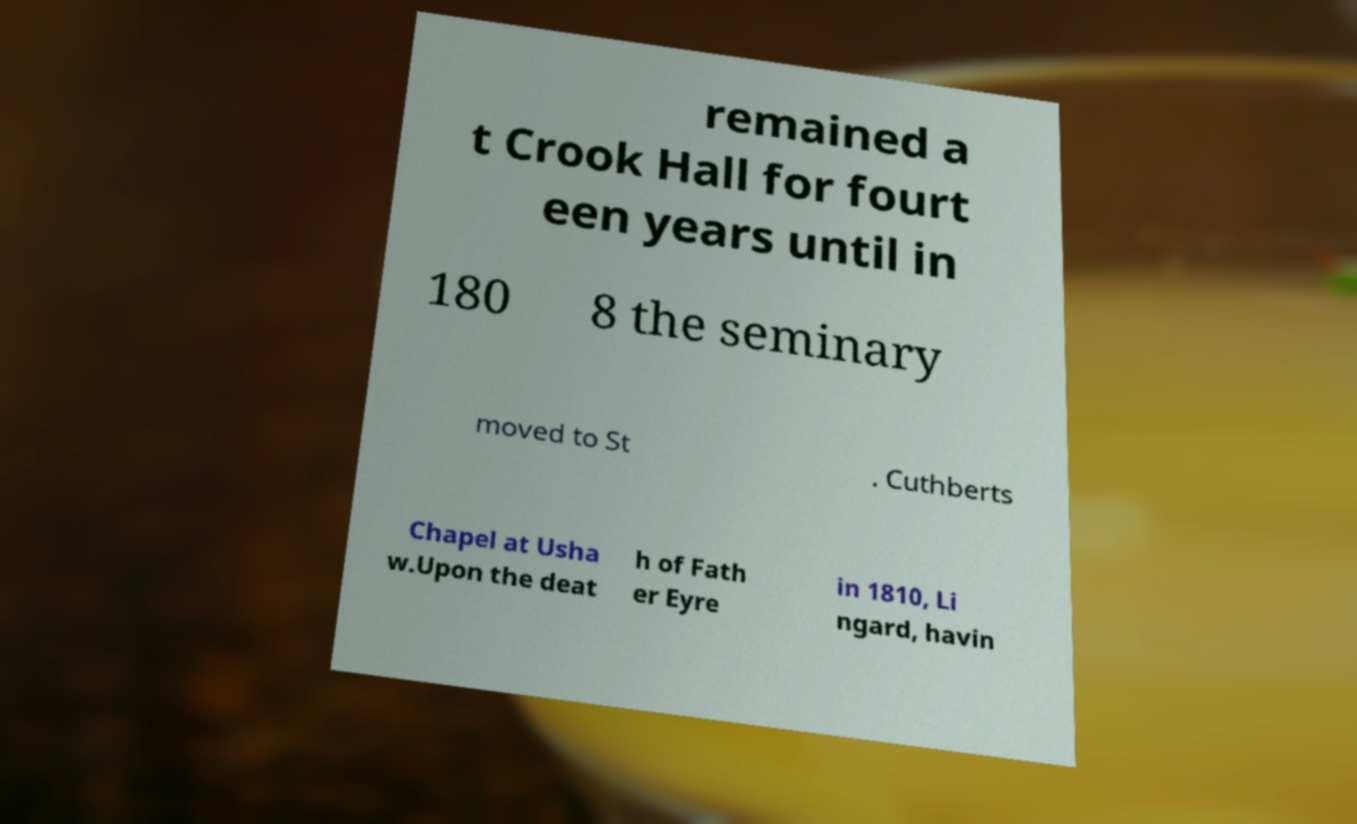There's text embedded in this image that I need extracted. Can you transcribe it verbatim? remained a t Crook Hall for fourt een years until in 180 8 the seminary moved to St . Cuthberts Chapel at Usha w.Upon the deat h of Fath er Eyre in 1810, Li ngard, havin 